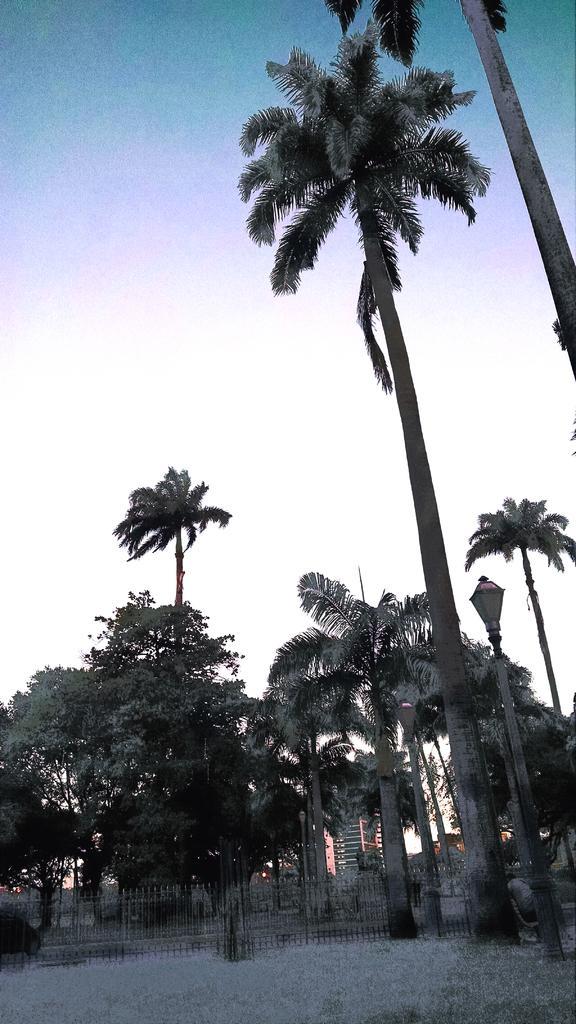Please provide a concise description of this image. Here we can see a fence, trees, poles, lights, and buildings. In the background there is sky. 